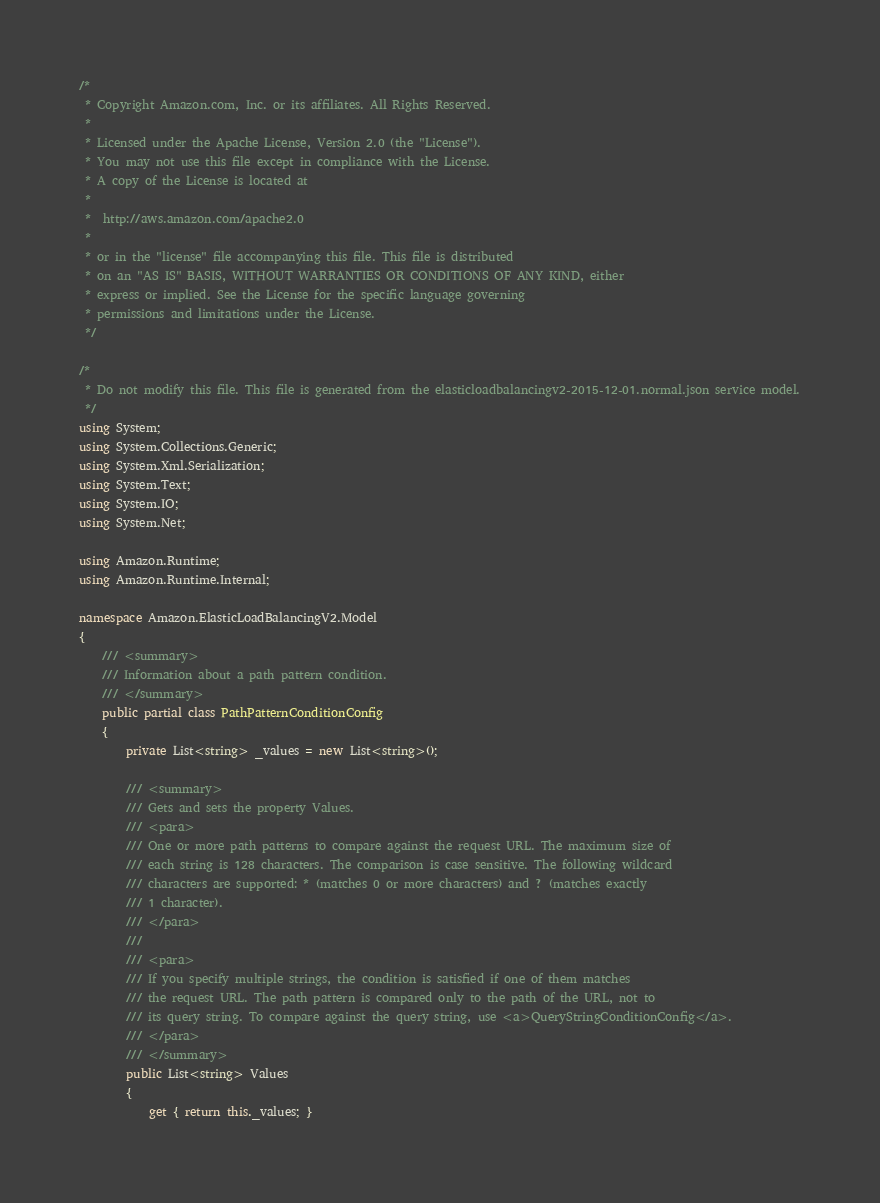<code> <loc_0><loc_0><loc_500><loc_500><_C#_>/*
 * Copyright Amazon.com, Inc. or its affiliates. All Rights Reserved.
 * 
 * Licensed under the Apache License, Version 2.0 (the "License").
 * You may not use this file except in compliance with the License.
 * A copy of the License is located at
 * 
 *  http://aws.amazon.com/apache2.0
 * 
 * or in the "license" file accompanying this file. This file is distributed
 * on an "AS IS" BASIS, WITHOUT WARRANTIES OR CONDITIONS OF ANY KIND, either
 * express or implied. See the License for the specific language governing
 * permissions and limitations under the License.
 */

/*
 * Do not modify this file. This file is generated from the elasticloadbalancingv2-2015-12-01.normal.json service model.
 */
using System;
using System.Collections.Generic;
using System.Xml.Serialization;
using System.Text;
using System.IO;
using System.Net;

using Amazon.Runtime;
using Amazon.Runtime.Internal;

namespace Amazon.ElasticLoadBalancingV2.Model
{
    /// <summary>
    /// Information about a path pattern condition.
    /// </summary>
    public partial class PathPatternConditionConfig
    {
        private List<string> _values = new List<string>();

        /// <summary>
        /// Gets and sets the property Values. 
        /// <para>
        /// One or more path patterns to compare against the request URL. The maximum size of
        /// each string is 128 characters. The comparison is case sensitive. The following wildcard
        /// characters are supported: * (matches 0 or more characters) and ? (matches exactly
        /// 1 character).
        /// </para>
        ///  
        /// <para>
        /// If you specify multiple strings, the condition is satisfied if one of them matches
        /// the request URL. The path pattern is compared only to the path of the URL, not to
        /// its query string. To compare against the query string, use <a>QueryStringConditionConfig</a>.
        /// </para>
        /// </summary>
        public List<string> Values
        {
            get { return this._values; }</code> 